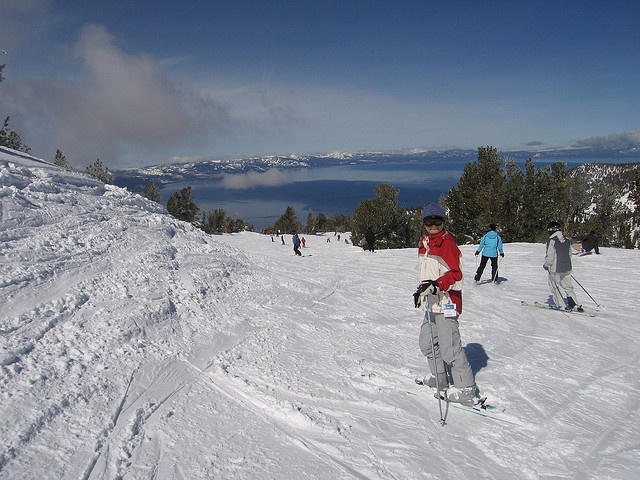Describe the objects in this image and their specific colors. I can see people in gray, darkgray, brown, and lightgray tones, people in gray, darkgray, and black tones, people in gray, black, darkgray, and lightgray tones, people in gray, black, lightblue, teal, and lightgray tones, and skis in gray, lightgray, and darkgray tones in this image. 